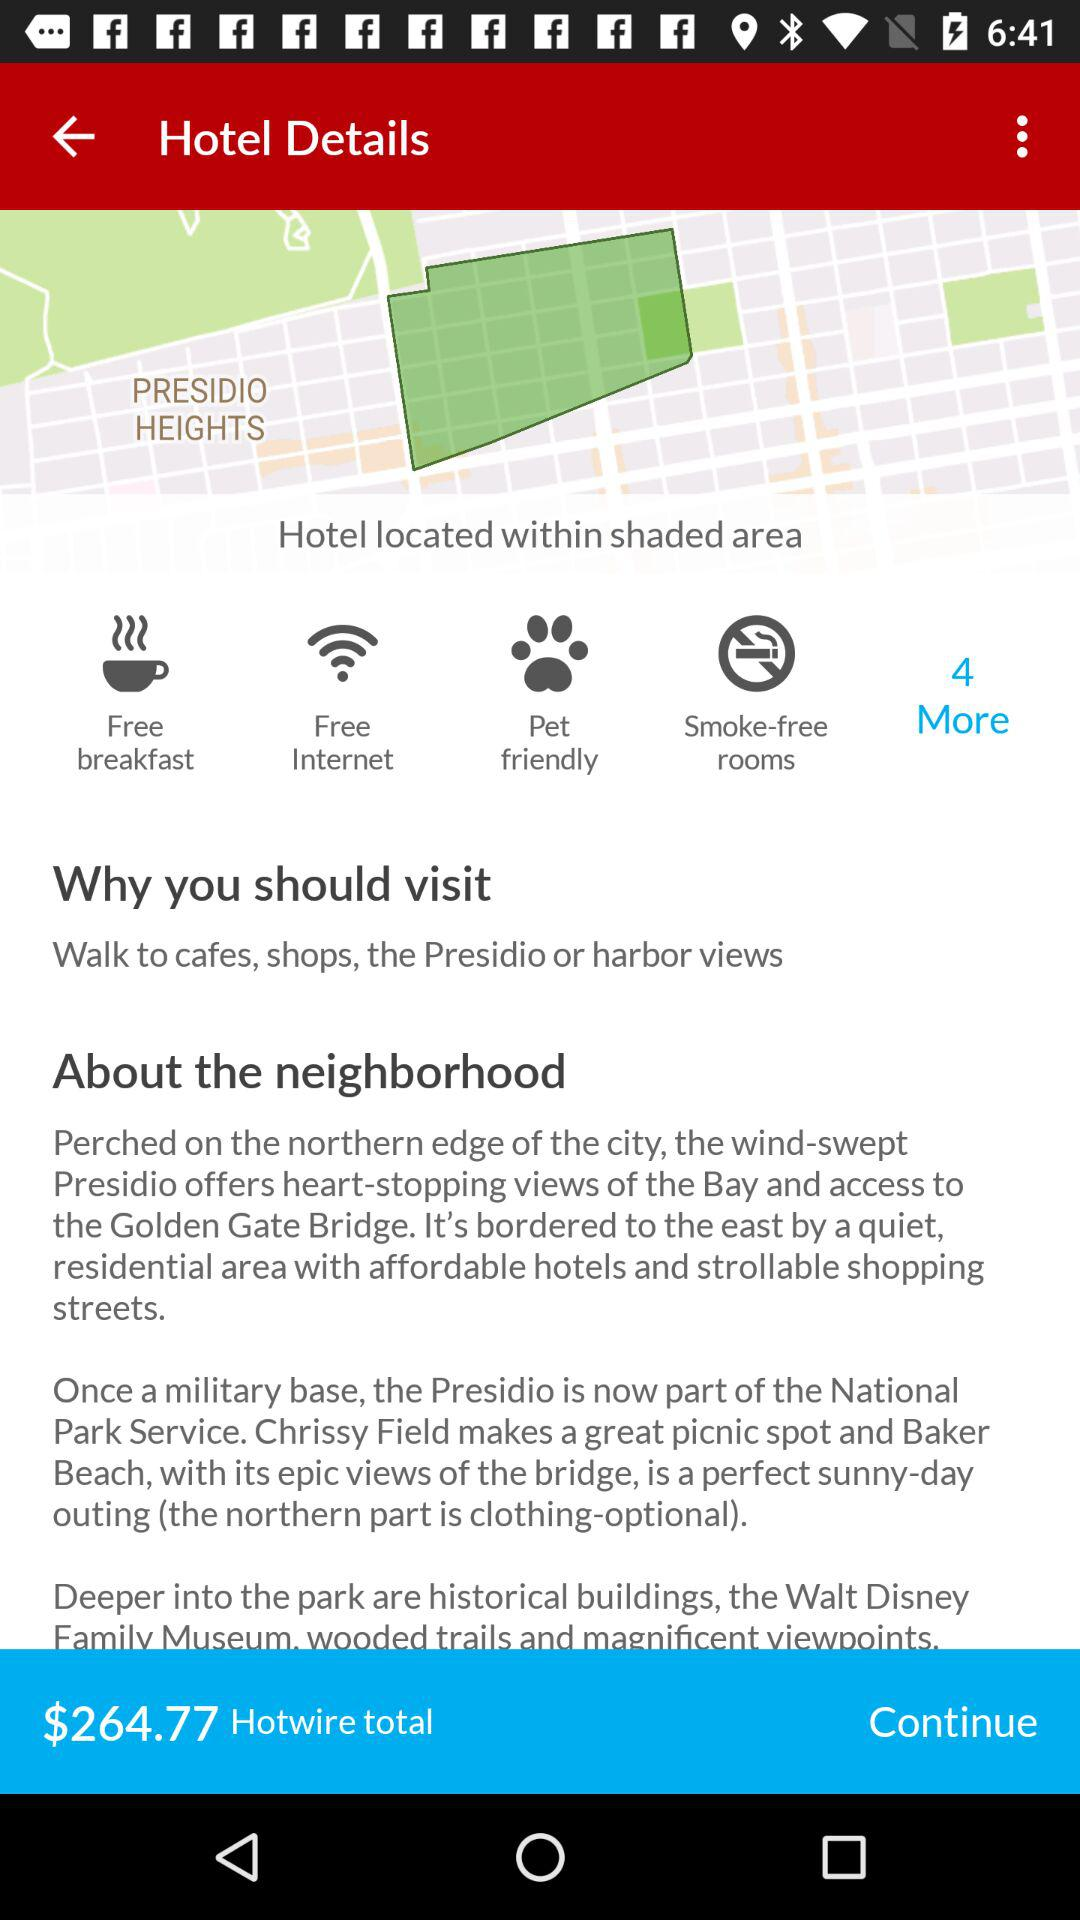How much is the total price of the hotel?
Answer the question using a single word or phrase. $264.77 